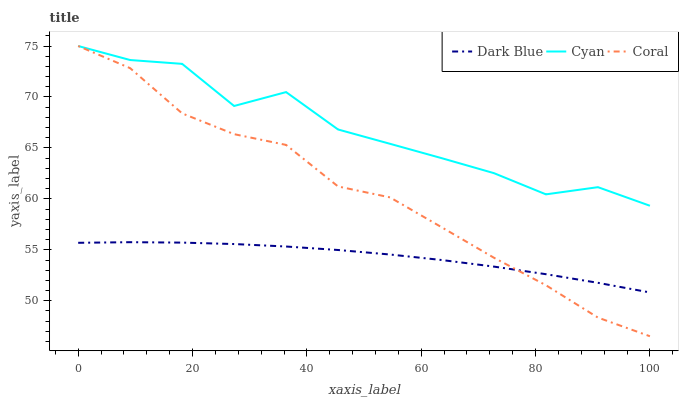Does Dark Blue have the minimum area under the curve?
Answer yes or no. Yes. Does Cyan have the maximum area under the curve?
Answer yes or no. Yes. Does Coral have the minimum area under the curve?
Answer yes or no. No. Does Coral have the maximum area under the curve?
Answer yes or no. No. Is Dark Blue the smoothest?
Answer yes or no. Yes. Is Cyan the roughest?
Answer yes or no. Yes. Is Coral the smoothest?
Answer yes or no. No. Is Coral the roughest?
Answer yes or no. No. Does Coral have the lowest value?
Answer yes or no. Yes. Does Cyan have the lowest value?
Answer yes or no. No. Does Cyan have the highest value?
Answer yes or no. Yes. Is Dark Blue less than Cyan?
Answer yes or no. Yes. Is Cyan greater than Dark Blue?
Answer yes or no. Yes. Does Coral intersect Dark Blue?
Answer yes or no. Yes. Is Coral less than Dark Blue?
Answer yes or no. No. Is Coral greater than Dark Blue?
Answer yes or no. No. Does Dark Blue intersect Cyan?
Answer yes or no. No. 